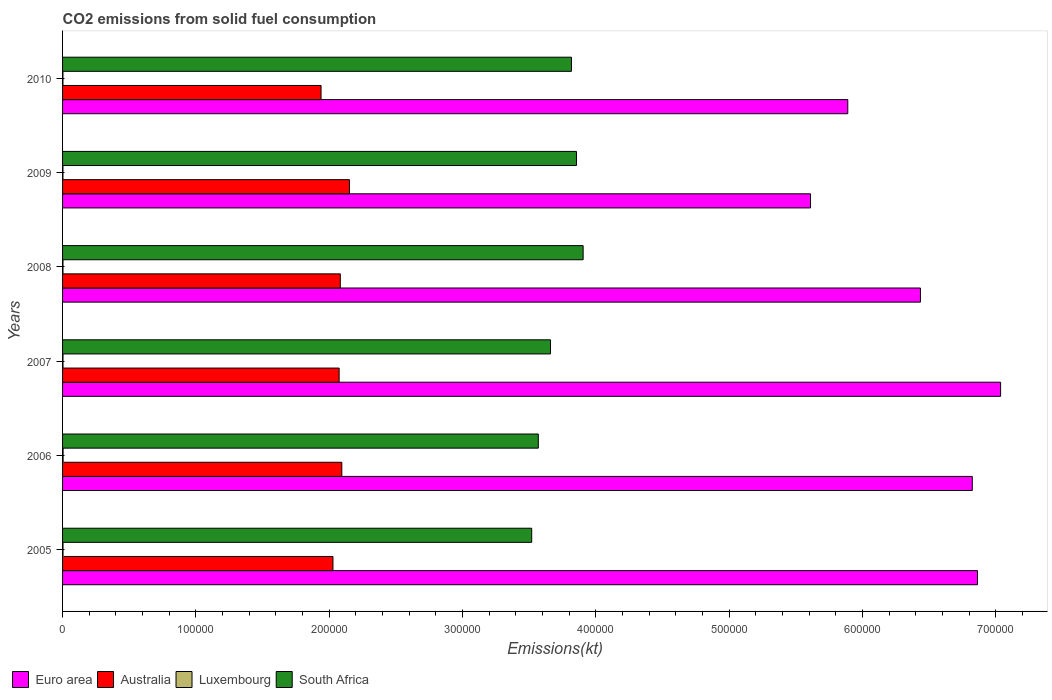Are the number of bars on each tick of the Y-axis equal?
Offer a terse response. Yes. How many bars are there on the 3rd tick from the top?
Your response must be concise. 4. How many bars are there on the 5th tick from the bottom?
Make the answer very short. 4. What is the label of the 1st group of bars from the top?
Offer a very short reply. 2010. What is the amount of CO2 emitted in South Africa in 2007?
Keep it short and to the point. 3.66e+05. Across all years, what is the maximum amount of CO2 emitted in Australia?
Keep it short and to the point. 2.15e+05. Across all years, what is the minimum amount of CO2 emitted in Australia?
Your answer should be very brief. 1.94e+05. In which year was the amount of CO2 emitted in Australia maximum?
Provide a succinct answer. 2009. What is the total amount of CO2 emitted in Australia in the graph?
Ensure brevity in your answer.  1.24e+06. What is the difference between the amount of CO2 emitted in Luxembourg in 2009 and that in 2010?
Offer a terse response. 3.67. What is the difference between the amount of CO2 emitted in South Africa in 2005 and the amount of CO2 emitted in Luxembourg in 2007?
Offer a terse response. 3.52e+05. What is the average amount of CO2 emitted in South Africa per year?
Make the answer very short. 3.72e+05. In the year 2010, what is the difference between the amount of CO2 emitted in Australia and amount of CO2 emitted in Euro area?
Provide a succinct answer. -3.95e+05. What is the ratio of the amount of CO2 emitted in Luxembourg in 2006 to that in 2010?
Your response must be concise. 1.38. Is the difference between the amount of CO2 emitted in Australia in 2005 and 2007 greater than the difference between the amount of CO2 emitted in Euro area in 2005 and 2007?
Ensure brevity in your answer.  Yes. What is the difference between the highest and the second highest amount of CO2 emitted in Australia?
Make the answer very short. 5716.85. What is the difference between the highest and the lowest amount of CO2 emitted in Luxembourg?
Offer a terse response. 110.01. Is it the case that in every year, the sum of the amount of CO2 emitted in Euro area and amount of CO2 emitted in Luxembourg is greater than the sum of amount of CO2 emitted in South Africa and amount of CO2 emitted in Australia?
Your response must be concise. No. Is it the case that in every year, the sum of the amount of CO2 emitted in South Africa and amount of CO2 emitted in Luxembourg is greater than the amount of CO2 emitted in Australia?
Offer a terse response. Yes. How many bars are there?
Ensure brevity in your answer.  24. How many years are there in the graph?
Offer a terse response. 6. What is the title of the graph?
Provide a short and direct response. CO2 emissions from solid fuel consumption. Does "Egypt, Arab Rep." appear as one of the legend labels in the graph?
Ensure brevity in your answer.  No. What is the label or title of the X-axis?
Ensure brevity in your answer.  Emissions(kt). What is the label or title of the Y-axis?
Provide a short and direct response. Years. What is the Emissions(kt) of Euro area in 2005?
Make the answer very short. 6.86e+05. What is the Emissions(kt) of Australia in 2005?
Give a very brief answer. 2.03e+05. What is the Emissions(kt) in Luxembourg in 2005?
Offer a terse response. 333.7. What is the Emissions(kt) of South Africa in 2005?
Provide a succinct answer. 3.52e+05. What is the Emissions(kt) in Euro area in 2006?
Your answer should be very brief. 6.82e+05. What is the Emissions(kt) of Australia in 2006?
Ensure brevity in your answer.  2.09e+05. What is the Emissions(kt) of Luxembourg in 2006?
Provide a short and direct response. 396.04. What is the Emissions(kt) in South Africa in 2006?
Give a very brief answer. 3.57e+05. What is the Emissions(kt) in Euro area in 2007?
Give a very brief answer. 7.04e+05. What is the Emissions(kt) in Australia in 2007?
Ensure brevity in your answer.  2.07e+05. What is the Emissions(kt) of Luxembourg in 2007?
Provide a succinct answer. 326.36. What is the Emissions(kt) in South Africa in 2007?
Offer a very short reply. 3.66e+05. What is the Emissions(kt) of Euro area in 2008?
Give a very brief answer. 6.44e+05. What is the Emissions(kt) in Australia in 2008?
Offer a terse response. 2.08e+05. What is the Emissions(kt) in Luxembourg in 2008?
Ensure brevity in your answer.  315.36. What is the Emissions(kt) of South Africa in 2008?
Offer a terse response. 3.91e+05. What is the Emissions(kt) in Euro area in 2009?
Provide a succinct answer. 5.61e+05. What is the Emissions(kt) of Australia in 2009?
Give a very brief answer. 2.15e+05. What is the Emissions(kt) of Luxembourg in 2009?
Your answer should be very brief. 289.69. What is the Emissions(kt) in South Africa in 2009?
Provide a succinct answer. 3.86e+05. What is the Emissions(kt) of Euro area in 2010?
Your answer should be very brief. 5.89e+05. What is the Emissions(kt) in Australia in 2010?
Your answer should be very brief. 1.94e+05. What is the Emissions(kt) of Luxembourg in 2010?
Your answer should be very brief. 286.03. What is the Emissions(kt) in South Africa in 2010?
Make the answer very short. 3.82e+05. Across all years, what is the maximum Emissions(kt) in Euro area?
Provide a succinct answer. 7.04e+05. Across all years, what is the maximum Emissions(kt) in Australia?
Give a very brief answer. 2.15e+05. Across all years, what is the maximum Emissions(kt) of Luxembourg?
Your answer should be very brief. 396.04. Across all years, what is the maximum Emissions(kt) of South Africa?
Keep it short and to the point. 3.91e+05. Across all years, what is the minimum Emissions(kt) of Euro area?
Offer a terse response. 5.61e+05. Across all years, what is the minimum Emissions(kt) of Australia?
Your response must be concise. 1.94e+05. Across all years, what is the minimum Emissions(kt) of Luxembourg?
Ensure brevity in your answer.  286.03. Across all years, what is the minimum Emissions(kt) of South Africa?
Ensure brevity in your answer.  3.52e+05. What is the total Emissions(kt) of Euro area in the graph?
Your answer should be very brief. 3.87e+06. What is the total Emissions(kt) in Australia in the graph?
Ensure brevity in your answer.  1.24e+06. What is the total Emissions(kt) in Luxembourg in the graph?
Offer a terse response. 1947.18. What is the total Emissions(kt) in South Africa in the graph?
Offer a very short reply. 2.23e+06. What is the difference between the Emissions(kt) of Euro area in 2005 and that in 2006?
Provide a short and direct response. 3892.87. What is the difference between the Emissions(kt) in Australia in 2005 and that in 2006?
Your answer should be compact. -6648.27. What is the difference between the Emissions(kt) in Luxembourg in 2005 and that in 2006?
Offer a terse response. -62.34. What is the difference between the Emissions(kt) in South Africa in 2005 and that in 2006?
Keep it short and to the point. -4954.12. What is the difference between the Emissions(kt) in Euro area in 2005 and that in 2007?
Keep it short and to the point. -1.73e+04. What is the difference between the Emissions(kt) in Australia in 2005 and that in 2007?
Offer a terse response. -4635.09. What is the difference between the Emissions(kt) of Luxembourg in 2005 and that in 2007?
Offer a terse response. 7.33. What is the difference between the Emissions(kt) in South Africa in 2005 and that in 2007?
Give a very brief answer. -1.41e+04. What is the difference between the Emissions(kt) of Euro area in 2005 and that in 2008?
Make the answer very short. 4.28e+04. What is the difference between the Emissions(kt) in Australia in 2005 and that in 2008?
Ensure brevity in your answer.  -5507.83. What is the difference between the Emissions(kt) of Luxembourg in 2005 and that in 2008?
Keep it short and to the point. 18.34. What is the difference between the Emissions(kt) in South Africa in 2005 and that in 2008?
Your answer should be compact. -3.86e+04. What is the difference between the Emissions(kt) in Euro area in 2005 and that in 2009?
Provide a succinct answer. 1.25e+05. What is the difference between the Emissions(kt) of Australia in 2005 and that in 2009?
Offer a terse response. -1.24e+04. What is the difference between the Emissions(kt) in Luxembourg in 2005 and that in 2009?
Ensure brevity in your answer.  44. What is the difference between the Emissions(kt) of South Africa in 2005 and that in 2009?
Your answer should be very brief. -3.36e+04. What is the difference between the Emissions(kt) of Euro area in 2005 and that in 2010?
Ensure brevity in your answer.  9.73e+04. What is the difference between the Emissions(kt) of Australia in 2005 and that in 2010?
Keep it short and to the point. 8929.15. What is the difference between the Emissions(kt) in Luxembourg in 2005 and that in 2010?
Offer a very short reply. 47.67. What is the difference between the Emissions(kt) of South Africa in 2005 and that in 2010?
Provide a short and direct response. -2.98e+04. What is the difference between the Emissions(kt) in Euro area in 2006 and that in 2007?
Your answer should be very brief. -2.12e+04. What is the difference between the Emissions(kt) of Australia in 2006 and that in 2007?
Give a very brief answer. 2013.18. What is the difference between the Emissions(kt) in Luxembourg in 2006 and that in 2007?
Offer a very short reply. 69.67. What is the difference between the Emissions(kt) of South Africa in 2006 and that in 2007?
Provide a succinct answer. -9156.5. What is the difference between the Emissions(kt) in Euro area in 2006 and that in 2008?
Your response must be concise. 3.89e+04. What is the difference between the Emissions(kt) of Australia in 2006 and that in 2008?
Ensure brevity in your answer.  1140.44. What is the difference between the Emissions(kt) in Luxembourg in 2006 and that in 2008?
Make the answer very short. 80.67. What is the difference between the Emissions(kt) of South Africa in 2006 and that in 2008?
Your answer should be compact. -3.36e+04. What is the difference between the Emissions(kt) in Euro area in 2006 and that in 2009?
Make the answer very short. 1.21e+05. What is the difference between the Emissions(kt) of Australia in 2006 and that in 2009?
Your answer should be compact. -5716.85. What is the difference between the Emissions(kt) in Luxembourg in 2006 and that in 2009?
Your answer should be very brief. 106.34. What is the difference between the Emissions(kt) of South Africa in 2006 and that in 2009?
Offer a terse response. -2.86e+04. What is the difference between the Emissions(kt) in Euro area in 2006 and that in 2010?
Offer a terse response. 9.34e+04. What is the difference between the Emissions(kt) in Australia in 2006 and that in 2010?
Offer a terse response. 1.56e+04. What is the difference between the Emissions(kt) in Luxembourg in 2006 and that in 2010?
Your answer should be compact. 110.01. What is the difference between the Emissions(kt) in South Africa in 2006 and that in 2010?
Provide a short and direct response. -2.49e+04. What is the difference between the Emissions(kt) in Euro area in 2007 and that in 2008?
Your answer should be very brief. 6.01e+04. What is the difference between the Emissions(kt) in Australia in 2007 and that in 2008?
Your answer should be compact. -872.75. What is the difference between the Emissions(kt) of Luxembourg in 2007 and that in 2008?
Your answer should be compact. 11. What is the difference between the Emissions(kt) of South Africa in 2007 and that in 2008?
Your answer should be very brief. -2.45e+04. What is the difference between the Emissions(kt) of Euro area in 2007 and that in 2009?
Provide a short and direct response. 1.43e+05. What is the difference between the Emissions(kt) of Australia in 2007 and that in 2009?
Keep it short and to the point. -7730.04. What is the difference between the Emissions(kt) in Luxembourg in 2007 and that in 2009?
Provide a short and direct response. 36.67. What is the difference between the Emissions(kt) in South Africa in 2007 and that in 2009?
Give a very brief answer. -1.95e+04. What is the difference between the Emissions(kt) of Euro area in 2007 and that in 2010?
Offer a terse response. 1.15e+05. What is the difference between the Emissions(kt) of Australia in 2007 and that in 2010?
Your response must be concise. 1.36e+04. What is the difference between the Emissions(kt) of Luxembourg in 2007 and that in 2010?
Provide a succinct answer. 40.34. What is the difference between the Emissions(kt) of South Africa in 2007 and that in 2010?
Make the answer very short. -1.57e+04. What is the difference between the Emissions(kt) of Euro area in 2008 and that in 2009?
Provide a succinct answer. 8.25e+04. What is the difference between the Emissions(kt) of Australia in 2008 and that in 2009?
Give a very brief answer. -6857.29. What is the difference between the Emissions(kt) of Luxembourg in 2008 and that in 2009?
Keep it short and to the point. 25.67. What is the difference between the Emissions(kt) of South Africa in 2008 and that in 2009?
Provide a succinct answer. 4994.45. What is the difference between the Emissions(kt) of Euro area in 2008 and that in 2010?
Provide a succinct answer. 5.45e+04. What is the difference between the Emissions(kt) in Australia in 2008 and that in 2010?
Provide a short and direct response. 1.44e+04. What is the difference between the Emissions(kt) in Luxembourg in 2008 and that in 2010?
Offer a terse response. 29.34. What is the difference between the Emissions(kt) in South Africa in 2008 and that in 2010?
Give a very brief answer. 8764.13. What is the difference between the Emissions(kt) in Euro area in 2009 and that in 2010?
Your response must be concise. -2.79e+04. What is the difference between the Emissions(kt) of Australia in 2009 and that in 2010?
Give a very brief answer. 2.13e+04. What is the difference between the Emissions(kt) of Luxembourg in 2009 and that in 2010?
Give a very brief answer. 3.67. What is the difference between the Emissions(kt) of South Africa in 2009 and that in 2010?
Ensure brevity in your answer.  3769.68. What is the difference between the Emissions(kt) of Euro area in 2005 and the Emissions(kt) of Australia in 2006?
Offer a very short reply. 4.77e+05. What is the difference between the Emissions(kt) in Euro area in 2005 and the Emissions(kt) in Luxembourg in 2006?
Your response must be concise. 6.86e+05. What is the difference between the Emissions(kt) in Euro area in 2005 and the Emissions(kt) in South Africa in 2006?
Your answer should be compact. 3.29e+05. What is the difference between the Emissions(kt) in Australia in 2005 and the Emissions(kt) in Luxembourg in 2006?
Your answer should be compact. 2.02e+05. What is the difference between the Emissions(kt) in Australia in 2005 and the Emissions(kt) in South Africa in 2006?
Give a very brief answer. -1.54e+05. What is the difference between the Emissions(kt) of Luxembourg in 2005 and the Emissions(kt) of South Africa in 2006?
Provide a succinct answer. -3.57e+05. What is the difference between the Emissions(kt) of Euro area in 2005 and the Emissions(kt) of Australia in 2007?
Your answer should be very brief. 4.79e+05. What is the difference between the Emissions(kt) in Euro area in 2005 and the Emissions(kt) in Luxembourg in 2007?
Ensure brevity in your answer.  6.86e+05. What is the difference between the Emissions(kt) of Euro area in 2005 and the Emissions(kt) of South Africa in 2007?
Offer a very short reply. 3.20e+05. What is the difference between the Emissions(kt) of Australia in 2005 and the Emissions(kt) of Luxembourg in 2007?
Provide a short and direct response. 2.03e+05. What is the difference between the Emissions(kt) in Australia in 2005 and the Emissions(kt) in South Africa in 2007?
Provide a short and direct response. -1.63e+05. What is the difference between the Emissions(kt) in Luxembourg in 2005 and the Emissions(kt) in South Africa in 2007?
Your answer should be very brief. -3.66e+05. What is the difference between the Emissions(kt) of Euro area in 2005 and the Emissions(kt) of Australia in 2008?
Offer a very short reply. 4.78e+05. What is the difference between the Emissions(kt) of Euro area in 2005 and the Emissions(kt) of Luxembourg in 2008?
Make the answer very short. 6.86e+05. What is the difference between the Emissions(kt) in Euro area in 2005 and the Emissions(kt) in South Africa in 2008?
Provide a short and direct response. 2.96e+05. What is the difference between the Emissions(kt) of Australia in 2005 and the Emissions(kt) of Luxembourg in 2008?
Your response must be concise. 2.03e+05. What is the difference between the Emissions(kt) in Australia in 2005 and the Emissions(kt) in South Africa in 2008?
Ensure brevity in your answer.  -1.88e+05. What is the difference between the Emissions(kt) in Luxembourg in 2005 and the Emissions(kt) in South Africa in 2008?
Offer a very short reply. -3.90e+05. What is the difference between the Emissions(kt) of Euro area in 2005 and the Emissions(kt) of Australia in 2009?
Keep it short and to the point. 4.71e+05. What is the difference between the Emissions(kt) in Euro area in 2005 and the Emissions(kt) in Luxembourg in 2009?
Your answer should be very brief. 6.86e+05. What is the difference between the Emissions(kt) in Euro area in 2005 and the Emissions(kt) in South Africa in 2009?
Your answer should be compact. 3.01e+05. What is the difference between the Emissions(kt) in Australia in 2005 and the Emissions(kt) in Luxembourg in 2009?
Provide a short and direct response. 2.03e+05. What is the difference between the Emissions(kt) of Australia in 2005 and the Emissions(kt) of South Africa in 2009?
Provide a short and direct response. -1.83e+05. What is the difference between the Emissions(kt) of Luxembourg in 2005 and the Emissions(kt) of South Africa in 2009?
Keep it short and to the point. -3.85e+05. What is the difference between the Emissions(kt) of Euro area in 2005 and the Emissions(kt) of Australia in 2010?
Your answer should be compact. 4.92e+05. What is the difference between the Emissions(kt) of Euro area in 2005 and the Emissions(kt) of Luxembourg in 2010?
Offer a terse response. 6.86e+05. What is the difference between the Emissions(kt) of Euro area in 2005 and the Emissions(kt) of South Africa in 2010?
Offer a terse response. 3.05e+05. What is the difference between the Emissions(kt) of Australia in 2005 and the Emissions(kt) of Luxembourg in 2010?
Keep it short and to the point. 2.03e+05. What is the difference between the Emissions(kt) in Australia in 2005 and the Emissions(kt) in South Africa in 2010?
Provide a short and direct response. -1.79e+05. What is the difference between the Emissions(kt) of Luxembourg in 2005 and the Emissions(kt) of South Africa in 2010?
Keep it short and to the point. -3.81e+05. What is the difference between the Emissions(kt) in Euro area in 2006 and the Emissions(kt) in Australia in 2007?
Ensure brevity in your answer.  4.75e+05. What is the difference between the Emissions(kt) of Euro area in 2006 and the Emissions(kt) of Luxembourg in 2007?
Your response must be concise. 6.82e+05. What is the difference between the Emissions(kt) of Euro area in 2006 and the Emissions(kt) of South Africa in 2007?
Keep it short and to the point. 3.16e+05. What is the difference between the Emissions(kt) in Australia in 2006 and the Emissions(kt) in Luxembourg in 2007?
Ensure brevity in your answer.  2.09e+05. What is the difference between the Emissions(kt) of Australia in 2006 and the Emissions(kt) of South Africa in 2007?
Your answer should be compact. -1.57e+05. What is the difference between the Emissions(kt) of Luxembourg in 2006 and the Emissions(kt) of South Africa in 2007?
Offer a terse response. -3.66e+05. What is the difference between the Emissions(kt) of Euro area in 2006 and the Emissions(kt) of Australia in 2008?
Your response must be concise. 4.74e+05. What is the difference between the Emissions(kt) in Euro area in 2006 and the Emissions(kt) in Luxembourg in 2008?
Ensure brevity in your answer.  6.82e+05. What is the difference between the Emissions(kt) in Euro area in 2006 and the Emissions(kt) in South Africa in 2008?
Your response must be concise. 2.92e+05. What is the difference between the Emissions(kt) of Australia in 2006 and the Emissions(kt) of Luxembourg in 2008?
Ensure brevity in your answer.  2.09e+05. What is the difference between the Emissions(kt) in Australia in 2006 and the Emissions(kt) in South Africa in 2008?
Provide a short and direct response. -1.81e+05. What is the difference between the Emissions(kt) of Luxembourg in 2006 and the Emissions(kt) of South Africa in 2008?
Offer a terse response. -3.90e+05. What is the difference between the Emissions(kt) of Euro area in 2006 and the Emissions(kt) of Australia in 2009?
Your answer should be very brief. 4.67e+05. What is the difference between the Emissions(kt) of Euro area in 2006 and the Emissions(kt) of Luxembourg in 2009?
Keep it short and to the point. 6.82e+05. What is the difference between the Emissions(kt) of Euro area in 2006 and the Emissions(kt) of South Africa in 2009?
Offer a terse response. 2.97e+05. What is the difference between the Emissions(kt) in Australia in 2006 and the Emissions(kt) in Luxembourg in 2009?
Provide a short and direct response. 2.09e+05. What is the difference between the Emissions(kt) in Australia in 2006 and the Emissions(kt) in South Africa in 2009?
Your answer should be very brief. -1.76e+05. What is the difference between the Emissions(kt) of Luxembourg in 2006 and the Emissions(kt) of South Africa in 2009?
Offer a very short reply. -3.85e+05. What is the difference between the Emissions(kt) of Euro area in 2006 and the Emissions(kt) of Australia in 2010?
Give a very brief answer. 4.89e+05. What is the difference between the Emissions(kt) of Euro area in 2006 and the Emissions(kt) of Luxembourg in 2010?
Keep it short and to the point. 6.82e+05. What is the difference between the Emissions(kt) of Euro area in 2006 and the Emissions(kt) of South Africa in 2010?
Give a very brief answer. 3.01e+05. What is the difference between the Emissions(kt) in Australia in 2006 and the Emissions(kt) in Luxembourg in 2010?
Provide a succinct answer. 2.09e+05. What is the difference between the Emissions(kt) in Australia in 2006 and the Emissions(kt) in South Africa in 2010?
Offer a very short reply. -1.72e+05. What is the difference between the Emissions(kt) in Luxembourg in 2006 and the Emissions(kt) in South Africa in 2010?
Offer a terse response. -3.81e+05. What is the difference between the Emissions(kt) of Euro area in 2007 and the Emissions(kt) of Australia in 2008?
Provide a succinct answer. 4.95e+05. What is the difference between the Emissions(kt) of Euro area in 2007 and the Emissions(kt) of Luxembourg in 2008?
Provide a short and direct response. 7.03e+05. What is the difference between the Emissions(kt) of Euro area in 2007 and the Emissions(kt) of South Africa in 2008?
Keep it short and to the point. 3.13e+05. What is the difference between the Emissions(kt) of Australia in 2007 and the Emissions(kt) of Luxembourg in 2008?
Make the answer very short. 2.07e+05. What is the difference between the Emissions(kt) in Australia in 2007 and the Emissions(kt) in South Africa in 2008?
Provide a short and direct response. -1.83e+05. What is the difference between the Emissions(kt) in Luxembourg in 2007 and the Emissions(kt) in South Africa in 2008?
Your answer should be very brief. -3.90e+05. What is the difference between the Emissions(kt) in Euro area in 2007 and the Emissions(kt) in Australia in 2009?
Offer a very short reply. 4.88e+05. What is the difference between the Emissions(kt) in Euro area in 2007 and the Emissions(kt) in Luxembourg in 2009?
Your answer should be very brief. 7.03e+05. What is the difference between the Emissions(kt) in Euro area in 2007 and the Emissions(kt) in South Africa in 2009?
Your answer should be very brief. 3.18e+05. What is the difference between the Emissions(kt) of Australia in 2007 and the Emissions(kt) of Luxembourg in 2009?
Provide a succinct answer. 2.07e+05. What is the difference between the Emissions(kt) of Australia in 2007 and the Emissions(kt) of South Africa in 2009?
Your answer should be compact. -1.78e+05. What is the difference between the Emissions(kt) of Luxembourg in 2007 and the Emissions(kt) of South Africa in 2009?
Make the answer very short. -3.85e+05. What is the difference between the Emissions(kt) in Euro area in 2007 and the Emissions(kt) in Australia in 2010?
Your answer should be compact. 5.10e+05. What is the difference between the Emissions(kt) of Euro area in 2007 and the Emissions(kt) of Luxembourg in 2010?
Make the answer very short. 7.03e+05. What is the difference between the Emissions(kt) of Euro area in 2007 and the Emissions(kt) of South Africa in 2010?
Offer a very short reply. 3.22e+05. What is the difference between the Emissions(kt) in Australia in 2007 and the Emissions(kt) in Luxembourg in 2010?
Make the answer very short. 2.07e+05. What is the difference between the Emissions(kt) of Australia in 2007 and the Emissions(kt) of South Africa in 2010?
Provide a short and direct response. -1.74e+05. What is the difference between the Emissions(kt) of Luxembourg in 2007 and the Emissions(kt) of South Africa in 2010?
Make the answer very short. -3.81e+05. What is the difference between the Emissions(kt) in Euro area in 2008 and the Emissions(kt) in Australia in 2009?
Provide a succinct answer. 4.28e+05. What is the difference between the Emissions(kt) of Euro area in 2008 and the Emissions(kt) of Luxembourg in 2009?
Your answer should be very brief. 6.43e+05. What is the difference between the Emissions(kt) in Euro area in 2008 and the Emissions(kt) in South Africa in 2009?
Make the answer very short. 2.58e+05. What is the difference between the Emissions(kt) of Australia in 2008 and the Emissions(kt) of Luxembourg in 2009?
Provide a succinct answer. 2.08e+05. What is the difference between the Emissions(kt) in Australia in 2008 and the Emissions(kt) in South Africa in 2009?
Provide a succinct answer. -1.77e+05. What is the difference between the Emissions(kt) in Luxembourg in 2008 and the Emissions(kt) in South Africa in 2009?
Provide a short and direct response. -3.85e+05. What is the difference between the Emissions(kt) in Euro area in 2008 and the Emissions(kt) in Australia in 2010?
Offer a terse response. 4.50e+05. What is the difference between the Emissions(kt) of Euro area in 2008 and the Emissions(kt) of Luxembourg in 2010?
Ensure brevity in your answer.  6.43e+05. What is the difference between the Emissions(kt) in Euro area in 2008 and the Emissions(kt) in South Africa in 2010?
Offer a very short reply. 2.62e+05. What is the difference between the Emissions(kt) in Australia in 2008 and the Emissions(kt) in Luxembourg in 2010?
Your answer should be compact. 2.08e+05. What is the difference between the Emissions(kt) in Australia in 2008 and the Emissions(kt) in South Africa in 2010?
Offer a terse response. -1.73e+05. What is the difference between the Emissions(kt) of Luxembourg in 2008 and the Emissions(kt) of South Africa in 2010?
Provide a short and direct response. -3.81e+05. What is the difference between the Emissions(kt) of Euro area in 2009 and the Emissions(kt) of Australia in 2010?
Provide a short and direct response. 3.67e+05. What is the difference between the Emissions(kt) of Euro area in 2009 and the Emissions(kt) of Luxembourg in 2010?
Provide a succinct answer. 5.61e+05. What is the difference between the Emissions(kt) of Euro area in 2009 and the Emissions(kt) of South Africa in 2010?
Provide a short and direct response. 1.79e+05. What is the difference between the Emissions(kt) of Australia in 2009 and the Emissions(kt) of Luxembourg in 2010?
Give a very brief answer. 2.15e+05. What is the difference between the Emissions(kt) in Australia in 2009 and the Emissions(kt) in South Africa in 2010?
Your answer should be very brief. -1.67e+05. What is the difference between the Emissions(kt) of Luxembourg in 2009 and the Emissions(kt) of South Africa in 2010?
Make the answer very short. -3.81e+05. What is the average Emissions(kt) of Euro area per year?
Give a very brief answer. 6.44e+05. What is the average Emissions(kt) of Australia per year?
Make the answer very short. 2.06e+05. What is the average Emissions(kt) in Luxembourg per year?
Your answer should be very brief. 324.53. What is the average Emissions(kt) of South Africa per year?
Give a very brief answer. 3.72e+05. In the year 2005, what is the difference between the Emissions(kt) of Euro area and Emissions(kt) of Australia?
Make the answer very short. 4.83e+05. In the year 2005, what is the difference between the Emissions(kt) of Euro area and Emissions(kt) of Luxembourg?
Give a very brief answer. 6.86e+05. In the year 2005, what is the difference between the Emissions(kt) in Euro area and Emissions(kt) in South Africa?
Offer a terse response. 3.34e+05. In the year 2005, what is the difference between the Emissions(kt) in Australia and Emissions(kt) in Luxembourg?
Ensure brevity in your answer.  2.02e+05. In the year 2005, what is the difference between the Emissions(kt) of Australia and Emissions(kt) of South Africa?
Your answer should be very brief. -1.49e+05. In the year 2005, what is the difference between the Emissions(kt) in Luxembourg and Emissions(kt) in South Africa?
Offer a terse response. -3.52e+05. In the year 2006, what is the difference between the Emissions(kt) in Euro area and Emissions(kt) in Australia?
Your response must be concise. 4.73e+05. In the year 2006, what is the difference between the Emissions(kt) of Euro area and Emissions(kt) of Luxembourg?
Offer a terse response. 6.82e+05. In the year 2006, what is the difference between the Emissions(kt) of Euro area and Emissions(kt) of South Africa?
Provide a short and direct response. 3.26e+05. In the year 2006, what is the difference between the Emissions(kt) of Australia and Emissions(kt) of Luxembourg?
Provide a succinct answer. 2.09e+05. In the year 2006, what is the difference between the Emissions(kt) in Australia and Emissions(kt) in South Africa?
Make the answer very short. -1.47e+05. In the year 2006, what is the difference between the Emissions(kt) in Luxembourg and Emissions(kt) in South Africa?
Keep it short and to the point. -3.56e+05. In the year 2007, what is the difference between the Emissions(kt) in Euro area and Emissions(kt) in Australia?
Make the answer very short. 4.96e+05. In the year 2007, what is the difference between the Emissions(kt) in Euro area and Emissions(kt) in Luxembourg?
Provide a short and direct response. 7.03e+05. In the year 2007, what is the difference between the Emissions(kt) of Euro area and Emissions(kt) of South Africa?
Offer a terse response. 3.38e+05. In the year 2007, what is the difference between the Emissions(kt) in Australia and Emissions(kt) in Luxembourg?
Ensure brevity in your answer.  2.07e+05. In the year 2007, what is the difference between the Emissions(kt) in Australia and Emissions(kt) in South Africa?
Give a very brief answer. -1.59e+05. In the year 2007, what is the difference between the Emissions(kt) in Luxembourg and Emissions(kt) in South Africa?
Make the answer very short. -3.66e+05. In the year 2008, what is the difference between the Emissions(kt) in Euro area and Emissions(kt) in Australia?
Your answer should be compact. 4.35e+05. In the year 2008, what is the difference between the Emissions(kt) of Euro area and Emissions(kt) of Luxembourg?
Make the answer very short. 6.43e+05. In the year 2008, what is the difference between the Emissions(kt) of Euro area and Emissions(kt) of South Africa?
Your answer should be compact. 2.53e+05. In the year 2008, what is the difference between the Emissions(kt) in Australia and Emissions(kt) in Luxembourg?
Your answer should be compact. 2.08e+05. In the year 2008, what is the difference between the Emissions(kt) in Australia and Emissions(kt) in South Africa?
Your answer should be compact. -1.82e+05. In the year 2008, what is the difference between the Emissions(kt) of Luxembourg and Emissions(kt) of South Africa?
Offer a terse response. -3.90e+05. In the year 2009, what is the difference between the Emissions(kt) in Euro area and Emissions(kt) in Australia?
Ensure brevity in your answer.  3.46e+05. In the year 2009, what is the difference between the Emissions(kt) of Euro area and Emissions(kt) of Luxembourg?
Offer a very short reply. 5.61e+05. In the year 2009, what is the difference between the Emissions(kt) in Euro area and Emissions(kt) in South Africa?
Provide a short and direct response. 1.76e+05. In the year 2009, what is the difference between the Emissions(kt) of Australia and Emissions(kt) of Luxembourg?
Your response must be concise. 2.15e+05. In the year 2009, what is the difference between the Emissions(kt) in Australia and Emissions(kt) in South Africa?
Offer a very short reply. -1.70e+05. In the year 2009, what is the difference between the Emissions(kt) in Luxembourg and Emissions(kt) in South Africa?
Give a very brief answer. -3.85e+05. In the year 2010, what is the difference between the Emissions(kt) of Euro area and Emissions(kt) of Australia?
Ensure brevity in your answer.  3.95e+05. In the year 2010, what is the difference between the Emissions(kt) of Euro area and Emissions(kt) of Luxembourg?
Your answer should be compact. 5.89e+05. In the year 2010, what is the difference between the Emissions(kt) in Euro area and Emissions(kt) in South Africa?
Your answer should be very brief. 2.07e+05. In the year 2010, what is the difference between the Emissions(kt) in Australia and Emissions(kt) in Luxembourg?
Keep it short and to the point. 1.94e+05. In the year 2010, what is the difference between the Emissions(kt) of Australia and Emissions(kt) of South Africa?
Your answer should be very brief. -1.88e+05. In the year 2010, what is the difference between the Emissions(kt) of Luxembourg and Emissions(kt) of South Africa?
Offer a terse response. -3.81e+05. What is the ratio of the Emissions(kt) in Euro area in 2005 to that in 2006?
Offer a terse response. 1.01. What is the ratio of the Emissions(kt) of Australia in 2005 to that in 2006?
Your response must be concise. 0.97. What is the ratio of the Emissions(kt) of Luxembourg in 2005 to that in 2006?
Provide a short and direct response. 0.84. What is the ratio of the Emissions(kt) of South Africa in 2005 to that in 2006?
Offer a terse response. 0.99. What is the ratio of the Emissions(kt) of Euro area in 2005 to that in 2007?
Give a very brief answer. 0.98. What is the ratio of the Emissions(kt) of Australia in 2005 to that in 2007?
Your answer should be compact. 0.98. What is the ratio of the Emissions(kt) in Luxembourg in 2005 to that in 2007?
Make the answer very short. 1.02. What is the ratio of the Emissions(kt) in South Africa in 2005 to that in 2007?
Make the answer very short. 0.96. What is the ratio of the Emissions(kt) in Euro area in 2005 to that in 2008?
Give a very brief answer. 1.07. What is the ratio of the Emissions(kt) of Australia in 2005 to that in 2008?
Keep it short and to the point. 0.97. What is the ratio of the Emissions(kt) in Luxembourg in 2005 to that in 2008?
Your answer should be compact. 1.06. What is the ratio of the Emissions(kt) in South Africa in 2005 to that in 2008?
Your response must be concise. 0.9. What is the ratio of the Emissions(kt) of Euro area in 2005 to that in 2009?
Your answer should be very brief. 1.22. What is the ratio of the Emissions(kt) in Australia in 2005 to that in 2009?
Offer a terse response. 0.94. What is the ratio of the Emissions(kt) of Luxembourg in 2005 to that in 2009?
Offer a very short reply. 1.15. What is the ratio of the Emissions(kt) of South Africa in 2005 to that in 2009?
Provide a succinct answer. 0.91. What is the ratio of the Emissions(kt) of Euro area in 2005 to that in 2010?
Keep it short and to the point. 1.17. What is the ratio of the Emissions(kt) of Australia in 2005 to that in 2010?
Keep it short and to the point. 1.05. What is the ratio of the Emissions(kt) of South Africa in 2005 to that in 2010?
Give a very brief answer. 0.92. What is the ratio of the Emissions(kt) in Euro area in 2006 to that in 2007?
Give a very brief answer. 0.97. What is the ratio of the Emissions(kt) in Australia in 2006 to that in 2007?
Keep it short and to the point. 1.01. What is the ratio of the Emissions(kt) of Luxembourg in 2006 to that in 2007?
Your answer should be compact. 1.21. What is the ratio of the Emissions(kt) in Euro area in 2006 to that in 2008?
Offer a terse response. 1.06. What is the ratio of the Emissions(kt) of Australia in 2006 to that in 2008?
Provide a short and direct response. 1.01. What is the ratio of the Emissions(kt) in Luxembourg in 2006 to that in 2008?
Give a very brief answer. 1.26. What is the ratio of the Emissions(kt) in South Africa in 2006 to that in 2008?
Provide a short and direct response. 0.91. What is the ratio of the Emissions(kt) of Euro area in 2006 to that in 2009?
Ensure brevity in your answer.  1.22. What is the ratio of the Emissions(kt) of Australia in 2006 to that in 2009?
Your response must be concise. 0.97. What is the ratio of the Emissions(kt) in Luxembourg in 2006 to that in 2009?
Provide a short and direct response. 1.37. What is the ratio of the Emissions(kt) in South Africa in 2006 to that in 2009?
Your response must be concise. 0.93. What is the ratio of the Emissions(kt) in Euro area in 2006 to that in 2010?
Your answer should be compact. 1.16. What is the ratio of the Emissions(kt) of Australia in 2006 to that in 2010?
Make the answer very short. 1.08. What is the ratio of the Emissions(kt) in Luxembourg in 2006 to that in 2010?
Provide a short and direct response. 1.38. What is the ratio of the Emissions(kt) of South Africa in 2006 to that in 2010?
Offer a very short reply. 0.93. What is the ratio of the Emissions(kt) in Euro area in 2007 to that in 2008?
Keep it short and to the point. 1.09. What is the ratio of the Emissions(kt) of Australia in 2007 to that in 2008?
Your answer should be compact. 1. What is the ratio of the Emissions(kt) of Luxembourg in 2007 to that in 2008?
Your answer should be very brief. 1.03. What is the ratio of the Emissions(kt) of South Africa in 2007 to that in 2008?
Make the answer very short. 0.94. What is the ratio of the Emissions(kt) in Euro area in 2007 to that in 2009?
Your answer should be very brief. 1.25. What is the ratio of the Emissions(kt) in Australia in 2007 to that in 2009?
Give a very brief answer. 0.96. What is the ratio of the Emissions(kt) in Luxembourg in 2007 to that in 2009?
Your response must be concise. 1.13. What is the ratio of the Emissions(kt) of South Africa in 2007 to that in 2009?
Keep it short and to the point. 0.95. What is the ratio of the Emissions(kt) in Euro area in 2007 to that in 2010?
Ensure brevity in your answer.  1.19. What is the ratio of the Emissions(kt) in Australia in 2007 to that in 2010?
Your answer should be very brief. 1.07. What is the ratio of the Emissions(kt) in Luxembourg in 2007 to that in 2010?
Your answer should be very brief. 1.14. What is the ratio of the Emissions(kt) in South Africa in 2007 to that in 2010?
Ensure brevity in your answer.  0.96. What is the ratio of the Emissions(kt) in Euro area in 2008 to that in 2009?
Offer a terse response. 1.15. What is the ratio of the Emissions(kt) in Australia in 2008 to that in 2009?
Keep it short and to the point. 0.97. What is the ratio of the Emissions(kt) of Luxembourg in 2008 to that in 2009?
Offer a terse response. 1.09. What is the ratio of the Emissions(kt) in South Africa in 2008 to that in 2009?
Your answer should be compact. 1.01. What is the ratio of the Emissions(kt) of Euro area in 2008 to that in 2010?
Your response must be concise. 1.09. What is the ratio of the Emissions(kt) in Australia in 2008 to that in 2010?
Offer a very short reply. 1.07. What is the ratio of the Emissions(kt) in Luxembourg in 2008 to that in 2010?
Offer a very short reply. 1.1. What is the ratio of the Emissions(kt) in Euro area in 2009 to that in 2010?
Give a very brief answer. 0.95. What is the ratio of the Emissions(kt) of Australia in 2009 to that in 2010?
Give a very brief answer. 1.11. What is the ratio of the Emissions(kt) in Luxembourg in 2009 to that in 2010?
Your response must be concise. 1.01. What is the ratio of the Emissions(kt) in South Africa in 2009 to that in 2010?
Ensure brevity in your answer.  1.01. What is the difference between the highest and the second highest Emissions(kt) in Euro area?
Offer a very short reply. 1.73e+04. What is the difference between the highest and the second highest Emissions(kt) in Australia?
Make the answer very short. 5716.85. What is the difference between the highest and the second highest Emissions(kt) of Luxembourg?
Ensure brevity in your answer.  62.34. What is the difference between the highest and the second highest Emissions(kt) of South Africa?
Your response must be concise. 4994.45. What is the difference between the highest and the lowest Emissions(kt) in Euro area?
Provide a succinct answer. 1.43e+05. What is the difference between the highest and the lowest Emissions(kt) in Australia?
Provide a succinct answer. 2.13e+04. What is the difference between the highest and the lowest Emissions(kt) in Luxembourg?
Offer a very short reply. 110.01. What is the difference between the highest and the lowest Emissions(kt) in South Africa?
Your answer should be very brief. 3.86e+04. 